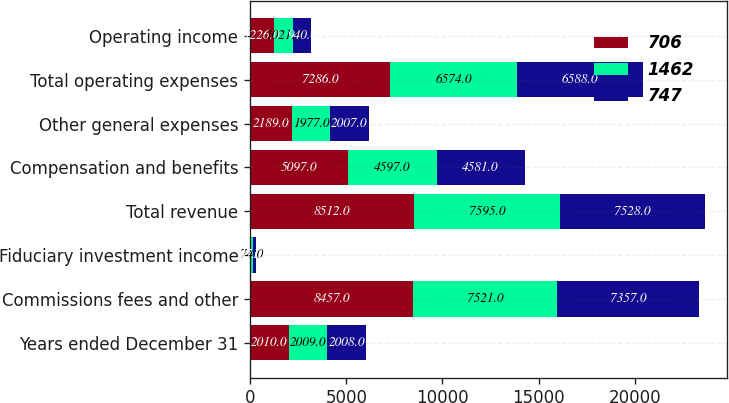Convert chart to OTSL. <chart><loc_0><loc_0><loc_500><loc_500><stacked_bar_chart><ecel><fcel>Years ended December 31<fcel>Commissions fees and other<fcel>Fiduciary investment income<fcel>Total revenue<fcel>Compensation and benefits<fcel>Other general expenses<fcel>Total operating expenses<fcel>Operating income<nl><fcel>706<fcel>2010<fcel>8457<fcel>55<fcel>8512<fcel>5097<fcel>2189<fcel>7286<fcel>1226<nl><fcel>1462<fcel>2009<fcel>7521<fcel>74<fcel>7595<fcel>4597<fcel>1977<fcel>6574<fcel>1021<nl><fcel>747<fcel>2008<fcel>7357<fcel>171<fcel>7528<fcel>4581<fcel>2007<fcel>6588<fcel>940<nl></chart> 